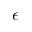Convert formula to latex. <formula><loc_0><loc_0><loc_500><loc_500>\epsilon</formula> 